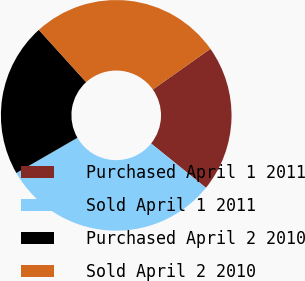<chart> <loc_0><loc_0><loc_500><loc_500><pie_chart><fcel>Purchased April 1 2011<fcel>Sold April 1 2011<fcel>Purchased April 2 2010<fcel>Sold April 2 2010<nl><fcel>20.6%<fcel>30.85%<fcel>21.63%<fcel>26.92%<nl></chart> 